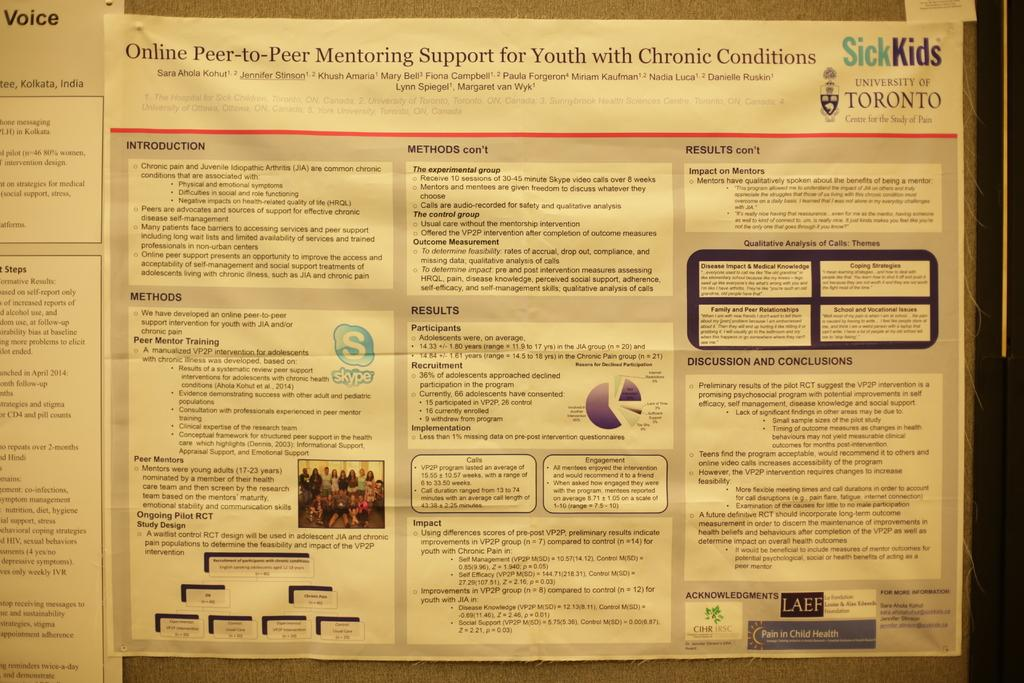Provide a one-sentence caption for the provided image. An informational page for children with chronic conditions by Sick Kids. 